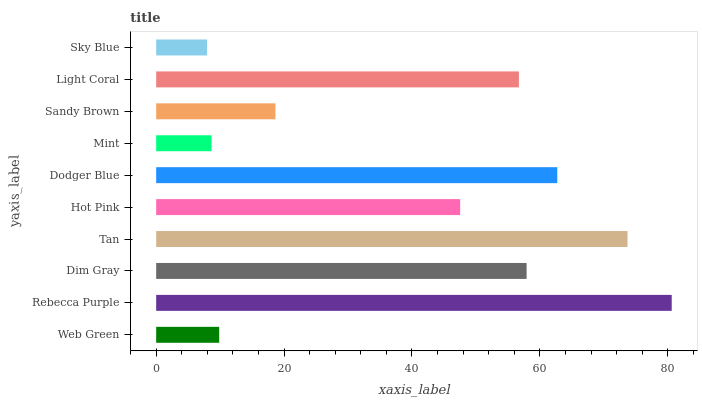Is Sky Blue the minimum?
Answer yes or no. Yes. Is Rebecca Purple the maximum?
Answer yes or no. Yes. Is Dim Gray the minimum?
Answer yes or no. No. Is Dim Gray the maximum?
Answer yes or no. No. Is Rebecca Purple greater than Dim Gray?
Answer yes or no. Yes. Is Dim Gray less than Rebecca Purple?
Answer yes or no. Yes. Is Dim Gray greater than Rebecca Purple?
Answer yes or no. No. Is Rebecca Purple less than Dim Gray?
Answer yes or no. No. Is Light Coral the high median?
Answer yes or no. Yes. Is Hot Pink the low median?
Answer yes or no. Yes. Is Dodger Blue the high median?
Answer yes or no. No. Is Dodger Blue the low median?
Answer yes or no. No. 